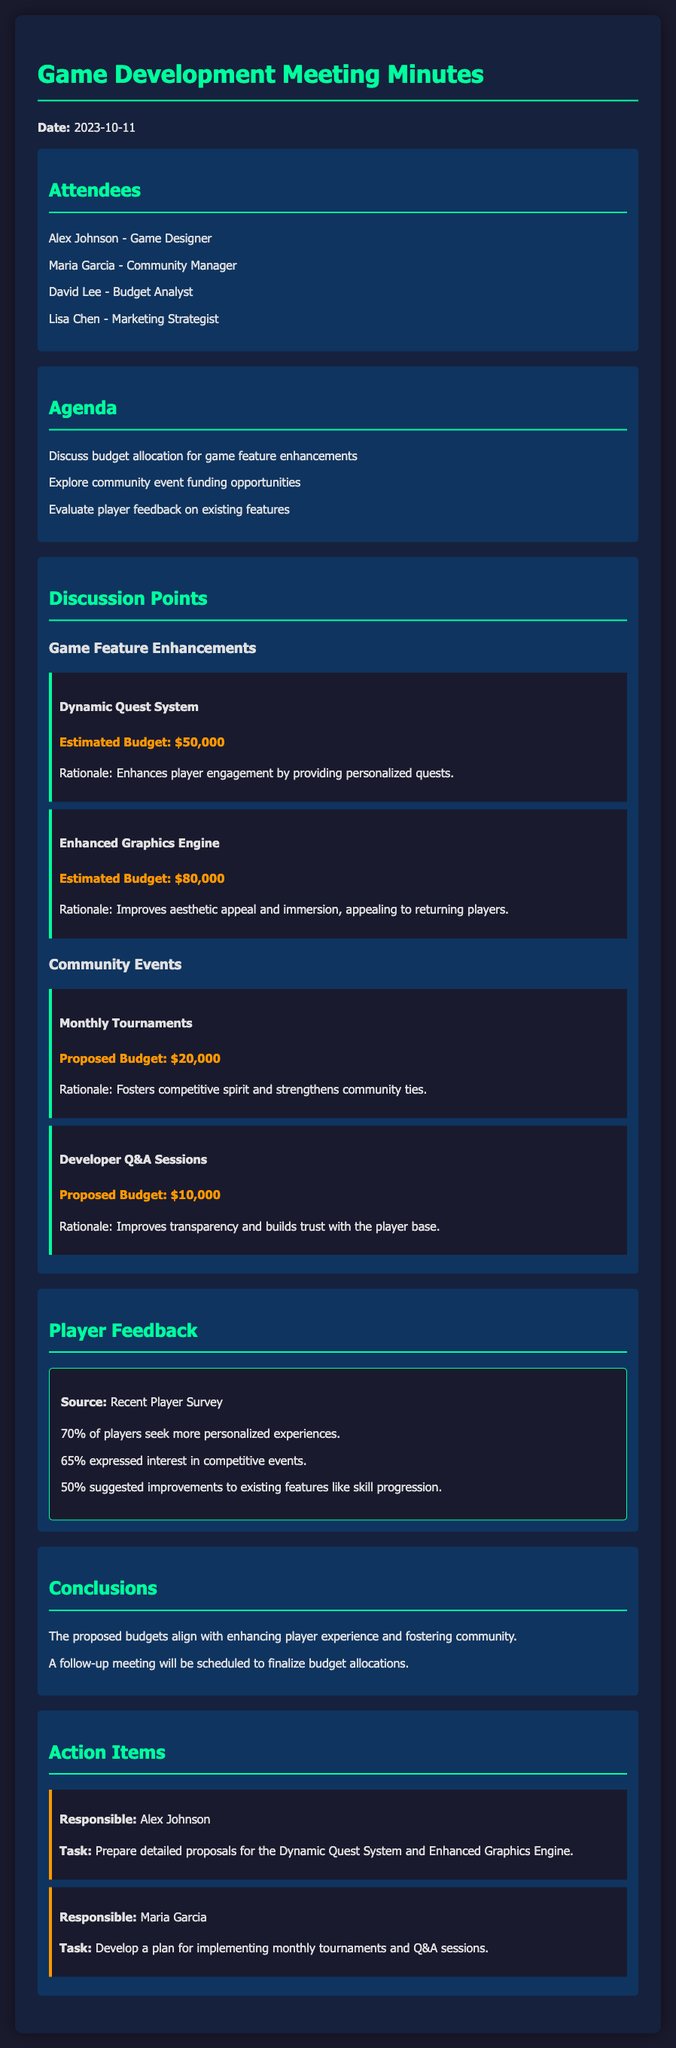what is the date of the meeting? The date of the meeting is mentioned at the beginning of the document.
Answer: 2023-10-11 who is responsible for preparing proposals for the Dynamic Quest System? The person's responsibility for preparing proposals is listed in the action items section.
Answer: Alex Johnson what is the estimated budget for the Enhanced Graphics Engine? The budget for the Enhanced Graphics Engine is stated under the game feature enhancements.
Answer: $80,000 how much funding is proposed for the Developer Q&A Sessions? The proposed budget for the Developer Q&A Sessions is indicated in the community events section.
Answer: $10,000 what percentage of players seek more personalized experiences? The percentage is highlighted in the player feedback section based on a recent survey.
Answer: 70% which community event aims to strengthen community ties? The community event that focuses on building community ties is specified in the discussion points.
Answer: Monthly Tournaments how many attendees were at the meeting? The number of attendees can be counted from the list provided in the document.
Answer: 4 what is the rationale for implementing the Dynamic Quest System? The reasoning for this feature enhancement can be found in the discussion points section.
Answer: Enhances player engagement by providing personalized quests 